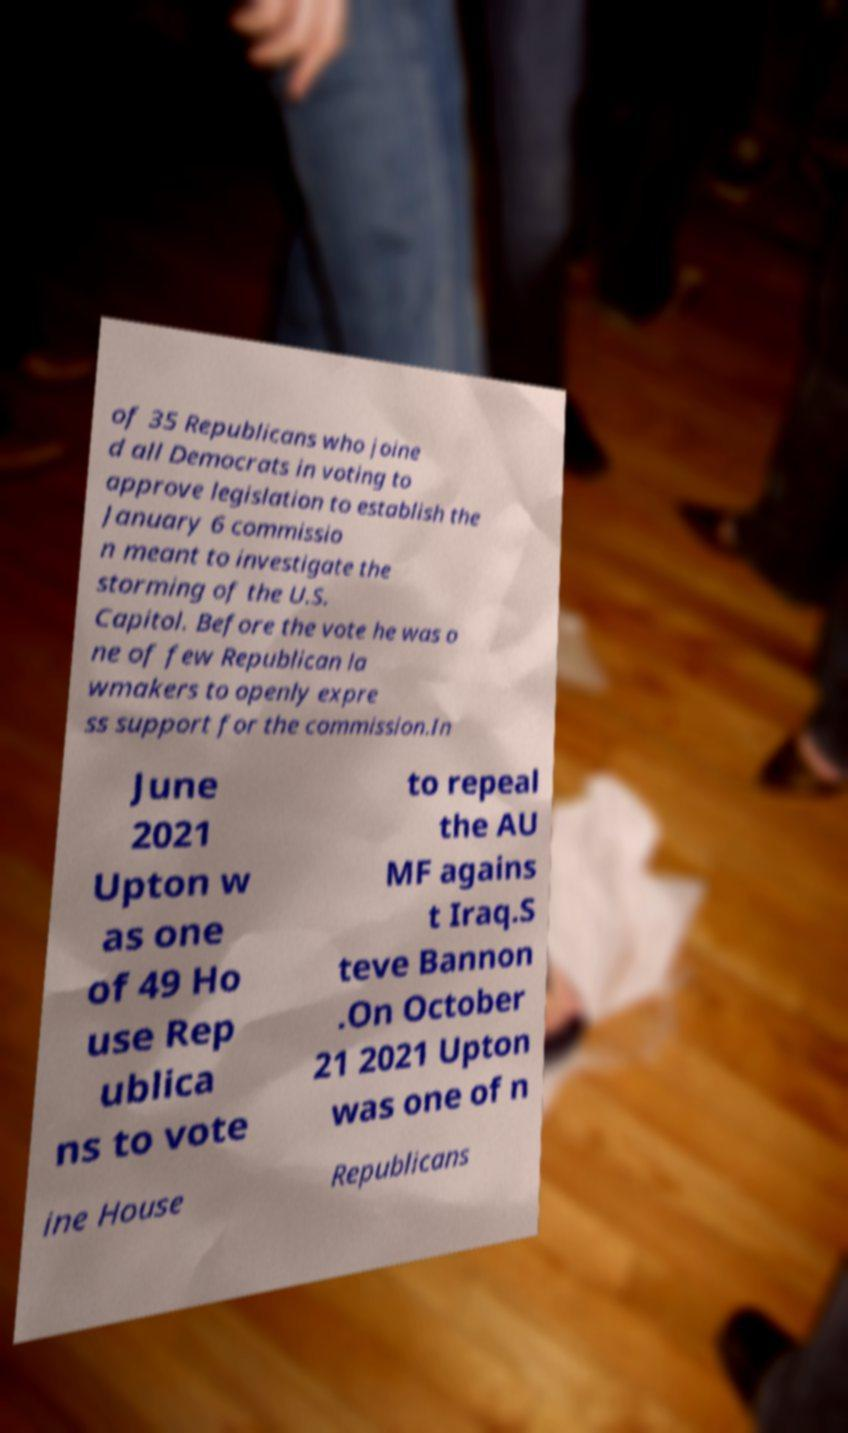I need the written content from this picture converted into text. Can you do that? of 35 Republicans who joine d all Democrats in voting to approve legislation to establish the January 6 commissio n meant to investigate the storming of the U.S. Capitol. Before the vote he was o ne of few Republican la wmakers to openly expre ss support for the commission.In June 2021 Upton w as one of 49 Ho use Rep ublica ns to vote to repeal the AU MF agains t Iraq.S teve Bannon .On October 21 2021 Upton was one of n ine House Republicans 